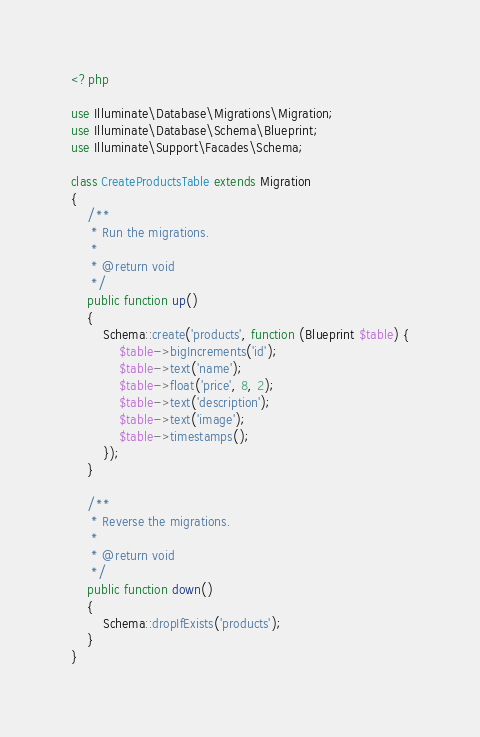<code> <loc_0><loc_0><loc_500><loc_500><_PHP_><?php

use Illuminate\Database\Migrations\Migration;
use Illuminate\Database\Schema\Blueprint;
use Illuminate\Support\Facades\Schema;

class CreateProductsTable extends Migration
{
    /**
     * Run the migrations.
     *
     * @return void
     */
    public function up()
    {
        Schema::create('products', function (Blueprint $table) {
            $table->bigIncrements('id');
            $table->text('name');
            $table->float('price', 8, 2);
            $table->text('description');
            $table->text('image');
            $table->timestamps();
        });
    }

    /**
     * Reverse the migrations.
     *
     * @return void
     */
    public function down()
    {
        Schema::dropIfExists('products');
    }
}
</code> 